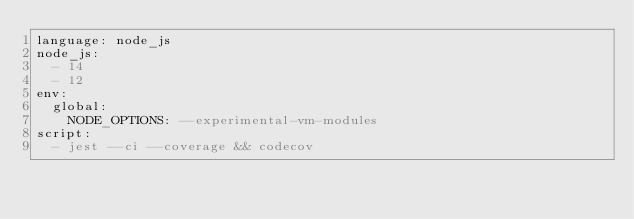Convert code to text. <code><loc_0><loc_0><loc_500><loc_500><_YAML_>language: node_js
node_js:
  - 14
  - 12
env:
  global:
    NODE_OPTIONS: --experimental-vm-modules
script:
  - jest --ci --coverage && codecov
</code> 